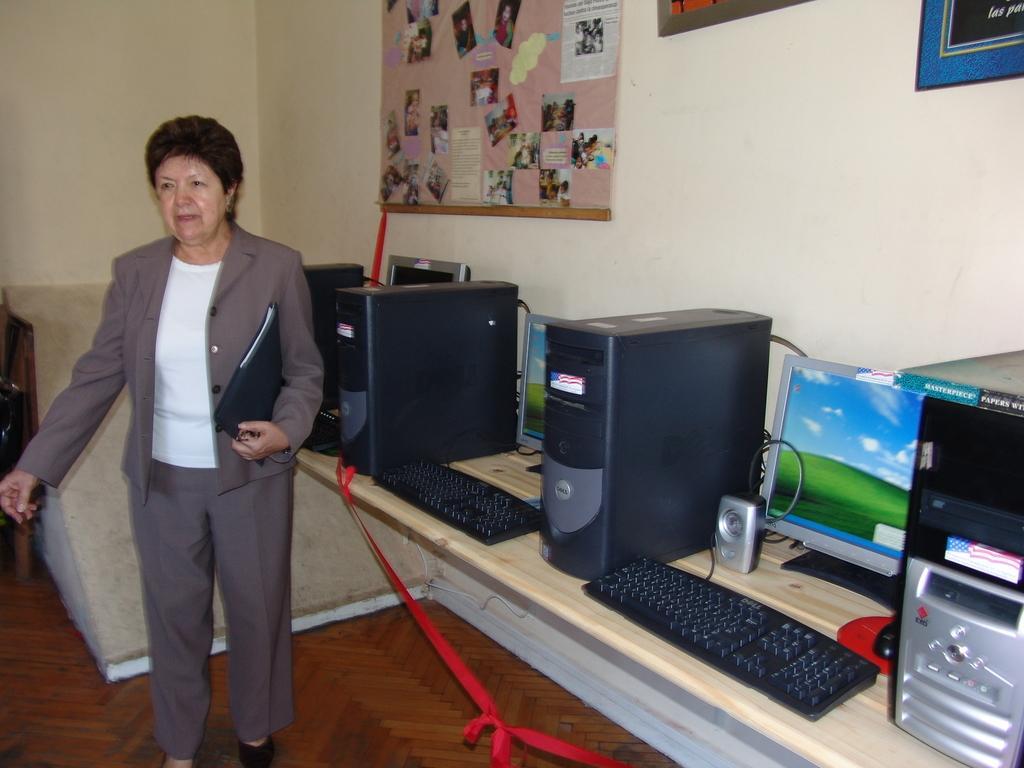Describe this image in one or two sentences. This women is wearing a suit, white color shirt, pant, and shoes. She is standing on the floor. And she is holding a file. Behind her, there is a CPU, monitor, keyboard and a desk. And there is a wall. On the wall, there is a poster. 